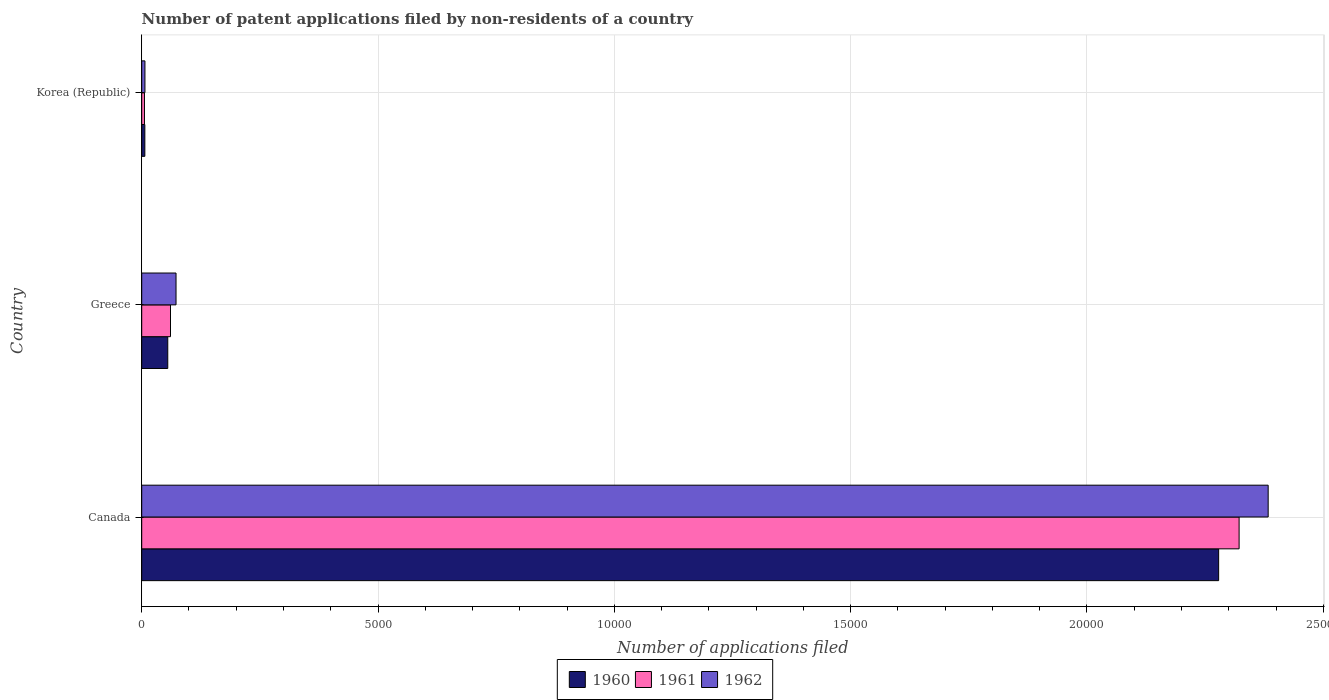How many different coloured bars are there?
Give a very brief answer. 3. Are the number of bars per tick equal to the number of legend labels?
Provide a short and direct response. Yes. How many bars are there on the 2nd tick from the top?
Keep it short and to the point. 3. What is the label of the 3rd group of bars from the top?
Ensure brevity in your answer.  Canada. In how many cases, is the number of bars for a given country not equal to the number of legend labels?
Offer a very short reply. 0. Across all countries, what is the maximum number of applications filed in 1962?
Make the answer very short. 2.38e+04. Across all countries, what is the minimum number of applications filed in 1962?
Your answer should be very brief. 68. In which country was the number of applications filed in 1961 maximum?
Offer a terse response. Canada. What is the total number of applications filed in 1960 in the graph?
Your answer should be very brief. 2.34e+04. What is the difference between the number of applications filed in 1960 in Canada and that in Greece?
Keep it short and to the point. 2.22e+04. What is the difference between the number of applications filed in 1961 in Greece and the number of applications filed in 1962 in Canada?
Ensure brevity in your answer.  -2.32e+04. What is the average number of applications filed in 1962 per country?
Offer a terse response. 8209.33. In how many countries, is the number of applications filed in 1961 greater than 12000 ?
Provide a succinct answer. 1. What is the ratio of the number of applications filed in 1960 in Canada to that in Korea (Republic)?
Make the answer very short. 345.24. Is the difference between the number of applications filed in 1960 in Canada and Korea (Republic) greater than the difference between the number of applications filed in 1962 in Canada and Korea (Republic)?
Offer a terse response. No. What is the difference between the highest and the second highest number of applications filed in 1961?
Offer a very short reply. 2.26e+04. What is the difference between the highest and the lowest number of applications filed in 1962?
Your answer should be very brief. 2.38e+04. In how many countries, is the number of applications filed in 1961 greater than the average number of applications filed in 1961 taken over all countries?
Your answer should be very brief. 1. What does the 2nd bar from the top in Greece represents?
Provide a succinct answer. 1961. What does the 1st bar from the bottom in Greece represents?
Provide a succinct answer. 1960. Are all the bars in the graph horizontal?
Offer a terse response. Yes. What is the difference between two consecutive major ticks on the X-axis?
Keep it short and to the point. 5000. Where does the legend appear in the graph?
Your response must be concise. Bottom center. How many legend labels are there?
Offer a terse response. 3. How are the legend labels stacked?
Your response must be concise. Horizontal. What is the title of the graph?
Provide a short and direct response. Number of patent applications filed by non-residents of a country. Does "1974" appear as one of the legend labels in the graph?
Make the answer very short. No. What is the label or title of the X-axis?
Your answer should be very brief. Number of applications filed. What is the Number of applications filed of 1960 in Canada?
Provide a succinct answer. 2.28e+04. What is the Number of applications filed in 1961 in Canada?
Your answer should be very brief. 2.32e+04. What is the Number of applications filed in 1962 in Canada?
Make the answer very short. 2.38e+04. What is the Number of applications filed of 1960 in Greece?
Your answer should be compact. 551. What is the Number of applications filed in 1961 in Greece?
Make the answer very short. 609. What is the Number of applications filed in 1962 in Greece?
Keep it short and to the point. 726. What is the Number of applications filed of 1961 in Korea (Republic)?
Your answer should be compact. 58. Across all countries, what is the maximum Number of applications filed of 1960?
Make the answer very short. 2.28e+04. Across all countries, what is the maximum Number of applications filed in 1961?
Your answer should be compact. 2.32e+04. Across all countries, what is the maximum Number of applications filed in 1962?
Your answer should be compact. 2.38e+04. Across all countries, what is the minimum Number of applications filed in 1961?
Make the answer very short. 58. Across all countries, what is the minimum Number of applications filed of 1962?
Your response must be concise. 68. What is the total Number of applications filed in 1960 in the graph?
Your answer should be very brief. 2.34e+04. What is the total Number of applications filed of 1961 in the graph?
Make the answer very short. 2.39e+04. What is the total Number of applications filed in 1962 in the graph?
Ensure brevity in your answer.  2.46e+04. What is the difference between the Number of applications filed in 1960 in Canada and that in Greece?
Give a very brief answer. 2.22e+04. What is the difference between the Number of applications filed of 1961 in Canada and that in Greece?
Provide a succinct answer. 2.26e+04. What is the difference between the Number of applications filed in 1962 in Canada and that in Greece?
Provide a short and direct response. 2.31e+04. What is the difference between the Number of applications filed in 1960 in Canada and that in Korea (Republic)?
Keep it short and to the point. 2.27e+04. What is the difference between the Number of applications filed in 1961 in Canada and that in Korea (Republic)?
Keep it short and to the point. 2.32e+04. What is the difference between the Number of applications filed in 1962 in Canada and that in Korea (Republic)?
Make the answer very short. 2.38e+04. What is the difference between the Number of applications filed in 1960 in Greece and that in Korea (Republic)?
Your response must be concise. 485. What is the difference between the Number of applications filed in 1961 in Greece and that in Korea (Republic)?
Your answer should be very brief. 551. What is the difference between the Number of applications filed in 1962 in Greece and that in Korea (Republic)?
Ensure brevity in your answer.  658. What is the difference between the Number of applications filed of 1960 in Canada and the Number of applications filed of 1961 in Greece?
Ensure brevity in your answer.  2.22e+04. What is the difference between the Number of applications filed of 1960 in Canada and the Number of applications filed of 1962 in Greece?
Make the answer very short. 2.21e+04. What is the difference between the Number of applications filed in 1961 in Canada and the Number of applications filed in 1962 in Greece?
Make the answer very short. 2.25e+04. What is the difference between the Number of applications filed of 1960 in Canada and the Number of applications filed of 1961 in Korea (Republic)?
Provide a succinct answer. 2.27e+04. What is the difference between the Number of applications filed of 1960 in Canada and the Number of applications filed of 1962 in Korea (Republic)?
Your response must be concise. 2.27e+04. What is the difference between the Number of applications filed of 1961 in Canada and the Number of applications filed of 1962 in Korea (Republic)?
Offer a very short reply. 2.32e+04. What is the difference between the Number of applications filed in 1960 in Greece and the Number of applications filed in 1961 in Korea (Republic)?
Your response must be concise. 493. What is the difference between the Number of applications filed in 1960 in Greece and the Number of applications filed in 1962 in Korea (Republic)?
Provide a succinct answer. 483. What is the difference between the Number of applications filed of 1961 in Greece and the Number of applications filed of 1962 in Korea (Republic)?
Provide a succinct answer. 541. What is the average Number of applications filed of 1960 per country?
Ensure brevity in your answer.  7801. What is the average Number of applications filed of 1961 per country?
Provide a succinct answer. 7962. What is the average Number of applications filed in 1962 per country?
Offer a terse response. 8209.33. What is the difference between the Number of applications filed of 1960 and Number of applications filed of 1961 in Canada?
Provide a short and direct response. -433. What is the difference between the Number of applications filed of 1960 and Number of applications filed of 1962 in Canada?
Your answer should be compact. -1048. What is the difference between the Number of applications filed in 1961 and Number of applications filed in 1962 in Canada?
Your response must be concise. -615. What is the difference between the Number of applications filed of 1960 and Number of applications filed of 1961 in Greece?
Keep it short and to the point. -58. What is the difference between the Number of applications filed of 1960 and Number of applications filed of 1962 in Greece?
Your answer should be very brief. -175. What is the difference between the Number of applications filed in 1961 and Number of applications filed in 1962 in Greece?
Provide a short and direct response. -117. What is the ratio of the Number of applications filed of 1960 in Canada to that in Greece?
Ensure brevity in your answer.  41.35. What is the ratio of the Number of applications filed of 1961 in Canada to that in Greece?
Provide a short and direct response. 38.13. What is the ratio of the Number of applications filed in 1962 in Canada to that in Greece?
Your answer should be very brief. 32.83. What is the ratio of the Number of applications filed in 1960 in Canada to that in Korea (Republic)?
Give a very brief answer. 345.24. What is the ratio of the Number of applications filed in 1961 in Canada to that in Korea (Republic)?
Ensure brevity in your answer.  400.33. What is the ratio of the Number of applications filed of 1962 in Canada to that in Korea (Republic)?
Offer a terse response. 350.5. What is the ratio of the Number of applications filed in 1960 in Greece to that in Korea (Republic)?
Make the answer very short. 8.35. What is the ratio of the Number of applications filed of 1962 in Greece to that in Korea (Republic)?
Ensure brevity in your answer.  10.68. What is the difference between the highest and the second highest Number of applications filed in 1960?
Keep it short and to the point. 2.22e+04. What is the difference between the highest and the second highest Number of applications filed in 1961?
Keep it short and to the point. 2.26e+04. What is the difference between the highest and the second highest Number of applications filed of 1962?
Make the answer very short. 2.31e+04. What is the difference between the highest and the lowest Number of applications filed in 1960?
Keep it short and to the point. 2.27e+04. What is the difference between the highest and the lowest Number of applications filed of 1961?
Your answer should be very brief. 2.32e+04. What is the difference between the highest and the lowest Number of applications filed in 1962?
Give a very brief answer. 2.38e+04. 